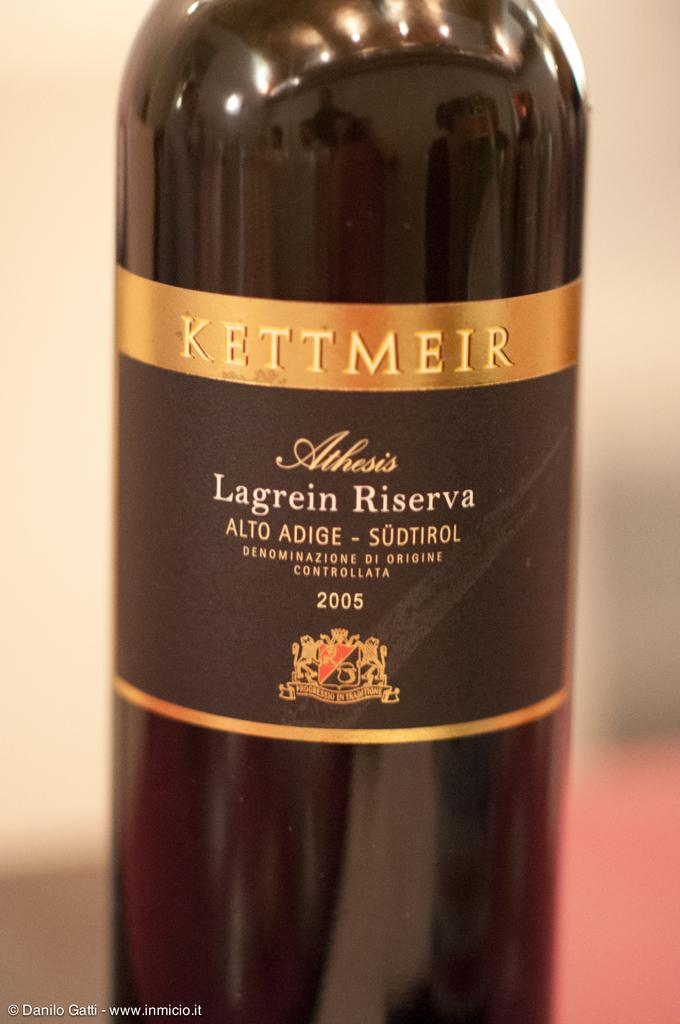<image>
Describe the image concisely. the year 2005 is present on a bottle 